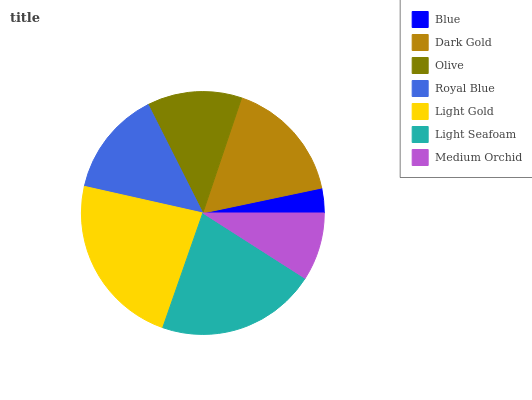Is Blue the minimum?
Answer yes or no. Yes. Is Light Gold the maximum?
Answer yes or no. Yes. Is Dark Gold the minimum?
Answer yes or no. No. Is Dark Gold the maximum?
Answer yes or no. No. Is Dark Gold greater than Blue?
Answer yes or no. Yes. Is Blue less than Dark Gold?
Answer yes or no. Yes. Is Blue greater than Dark Gold?
Answer yes or no. No. Is Dark Gold less than Blue?
Answer yes or no. No. Is Royal Blue the high median?
Answer yes or no. Yes. Is Royal Blue the low median?
Answer yes or no. Yes. Is Blue the high median?
Answer yes or no. No. Is Medium Orchid the low median?
Answer yes or no. No. 